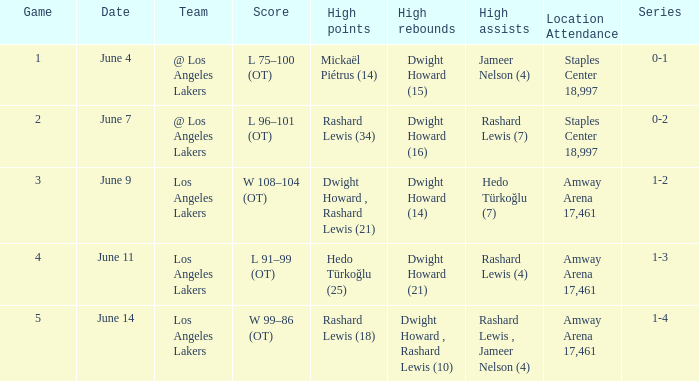If dwight howard's high rebounds are 16, what is the meaning of high points? Rashard Lewis (34). 